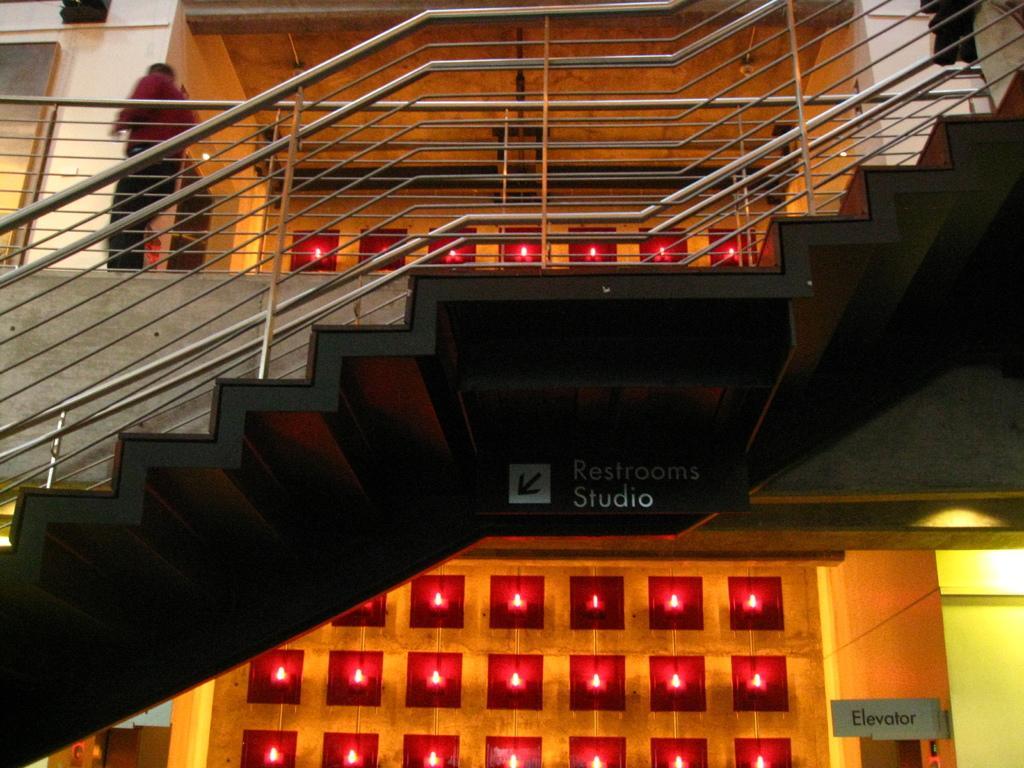Please provide a concise description of this image. Here is a person standing. These are the stairs with the staircase holders. This is the board, which is hanging to the roof. This looks like a decorated wall. 